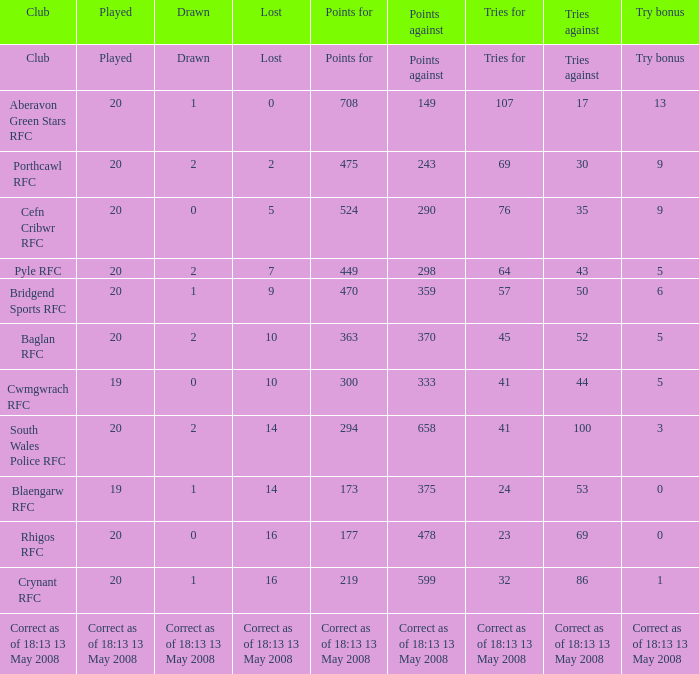When the tries against were 52, how many tries for were there? 45.0. 